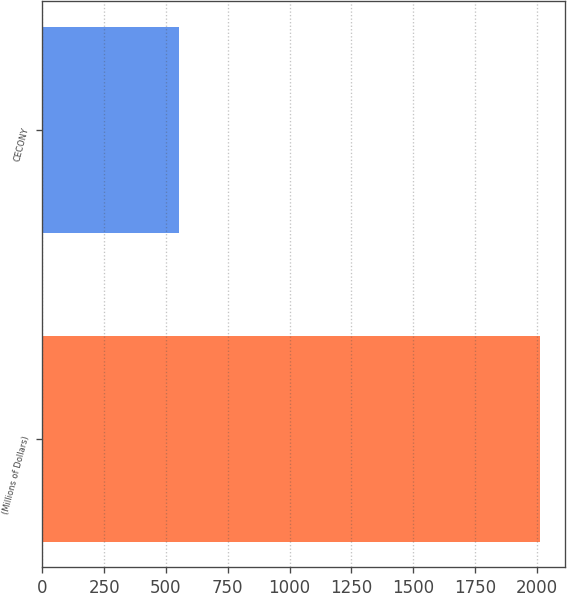<chart> <loc_0><loc_0><loc_500><loc_500><bar_chart><fcel>(Millions of Dollars)<fcel>CECONY<nl><fcel>2015<fcel>552<nl></chart> 